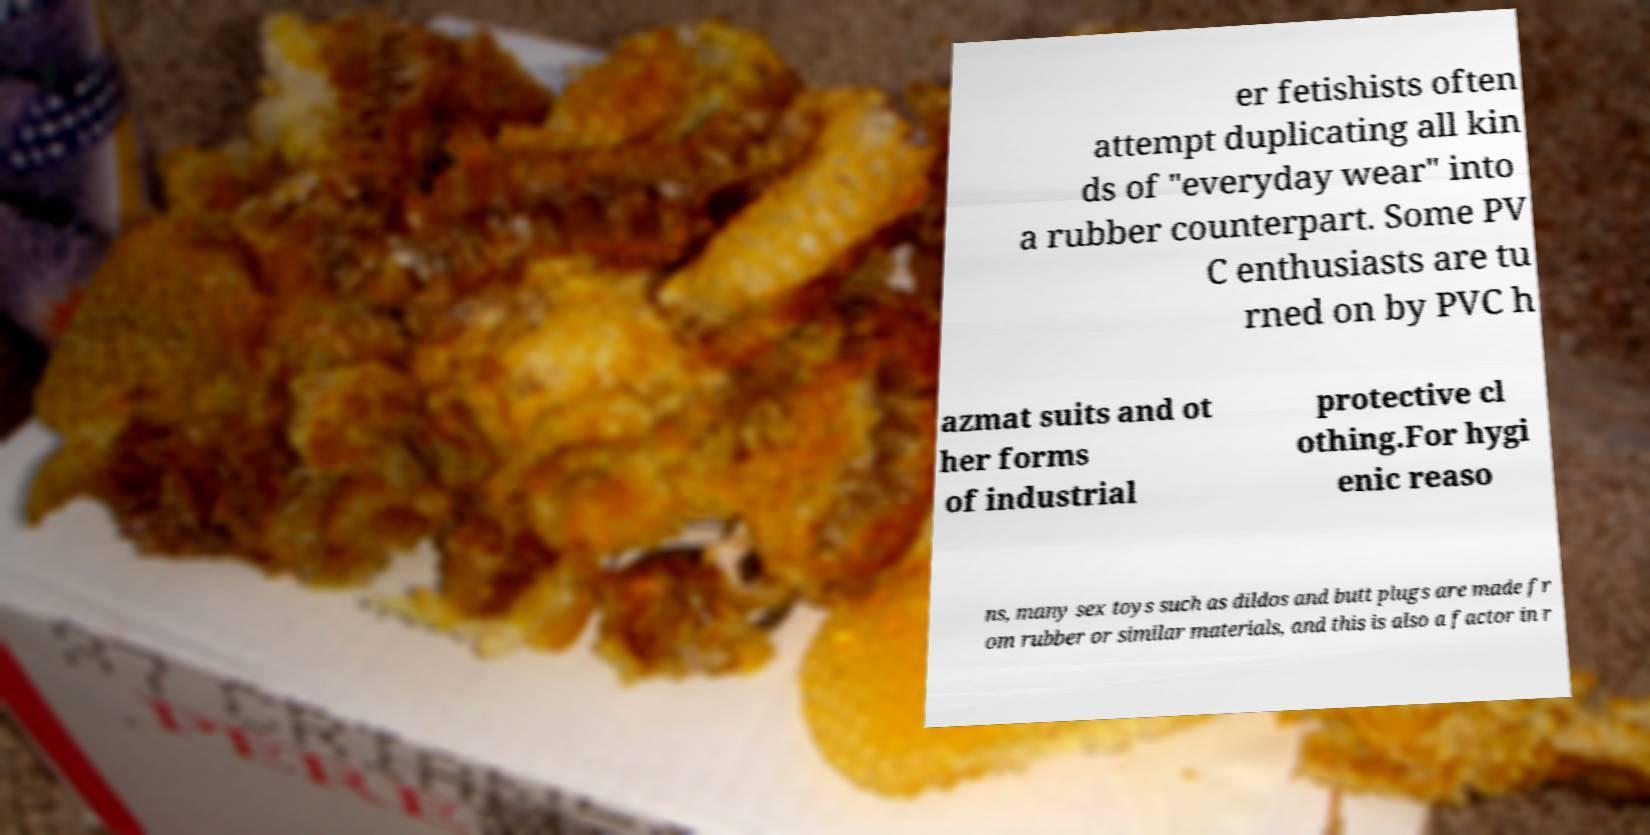For documentation purposes, I need the text within this image transcribed. Could you provide that? er fetishists often attempt duplicating all kin ds of "everyday wear" into a rubber counterpart. Some PV C enthusiasts are tu rned on by PVC h azmat suits and ot her forms of industrial protective cl othing.For hygi enic reaso ns, many sex toys such as dildos and butt plugs are made fr om rubber or similar materials, and this is also a factor in r 